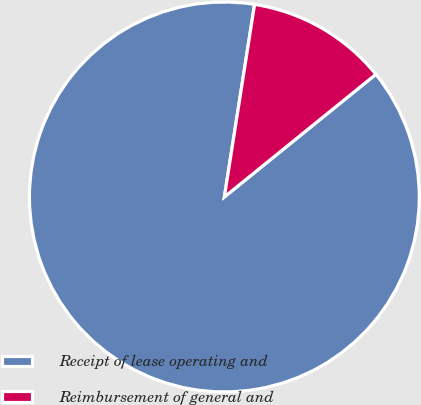<chart> <loc_0><loc_0><loc_500><loc_500><pie_chart><fcel>Receipt of lease operating and<fcel>Reimbursement of general and<nl><fcel>88.31%<fcel>11.69%<nl></chart> 